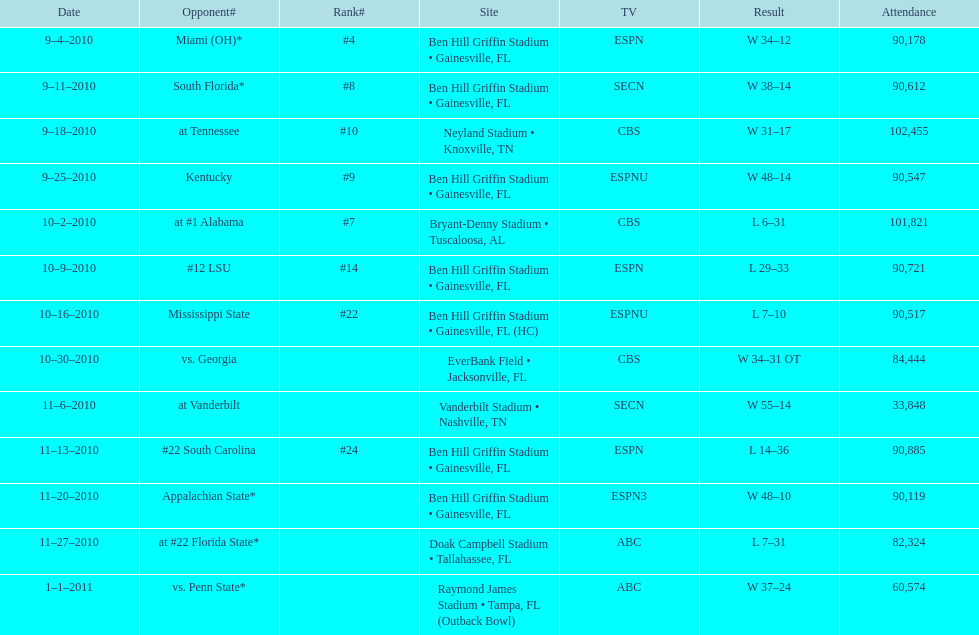Who was victorious in the preceding match? Gators. 